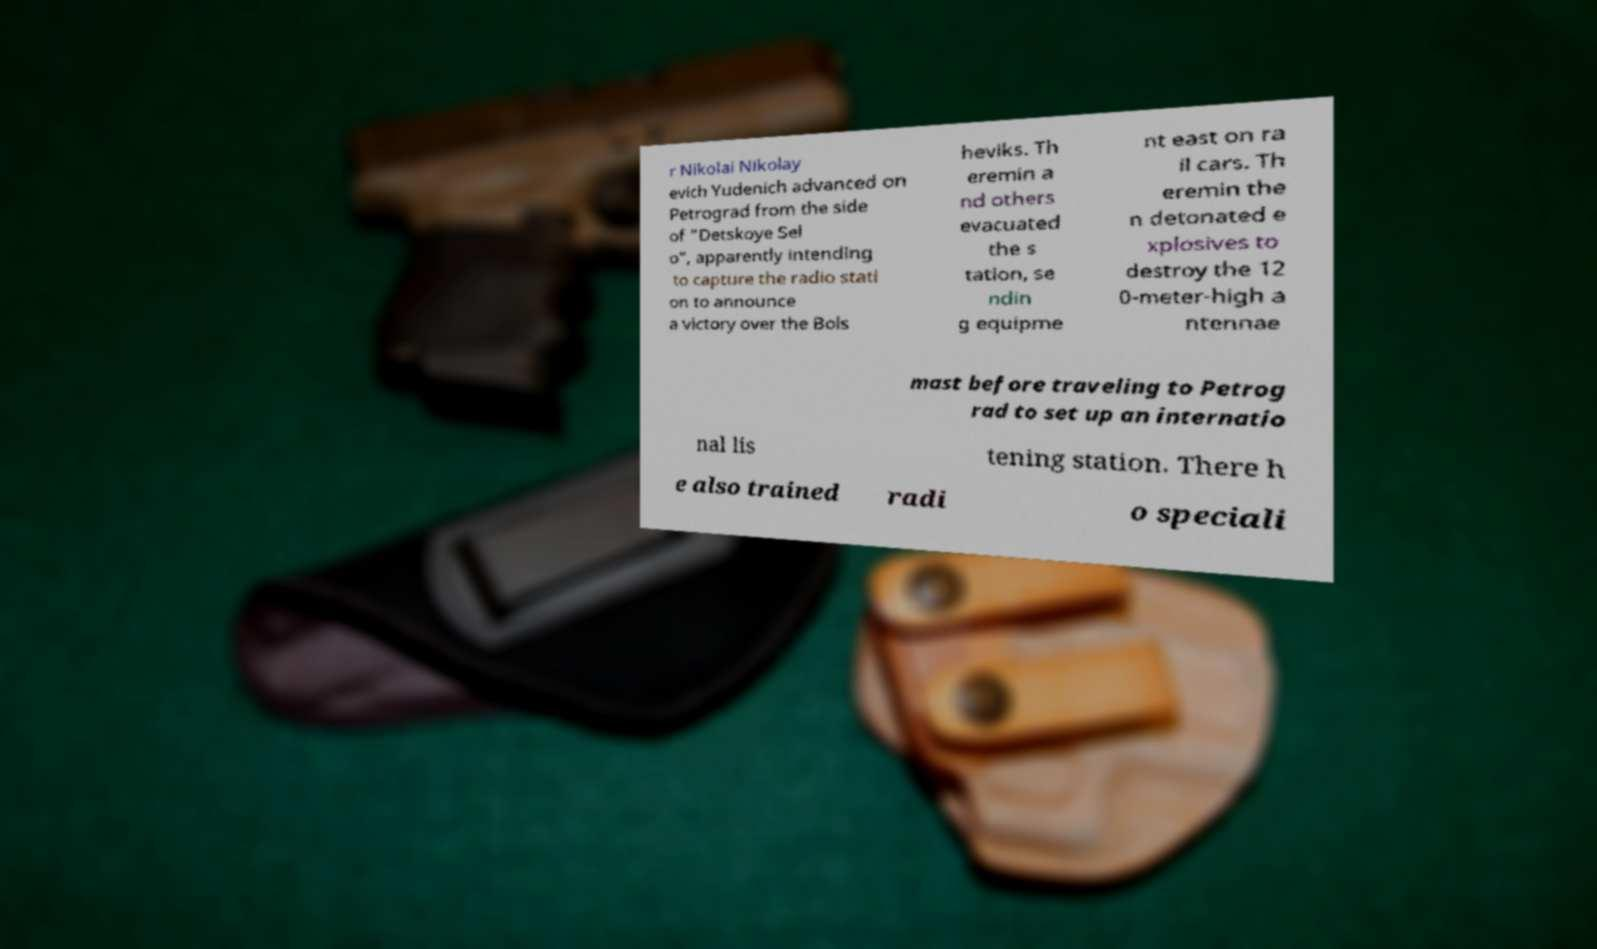Please read and relay the text visible in this image. What does it say? r Nikolai Nikolay evich Yudenich advanced on Petrograd from the side of "Detskoye Sel o", apparently intending to capture the radio stati on to announce a victory over the Bols heviks. Th eremin a nd others evacuated the s tation, se ndin g equipme nt east on ra il cars. Th eremin the n detonated e xplosives to destroy the 12 0-meter-high a ntennae mast before traveling to Petrog rad to set up an internatio nal lis tening station. There h e also trained radi o speciali 